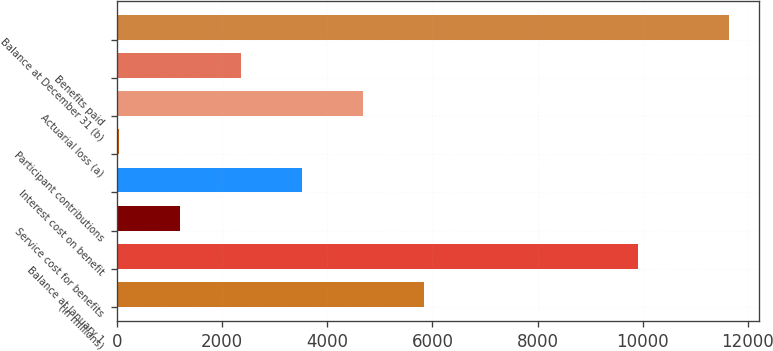<chart> <loc_0><loc_0><loc_500><loc_500><bar_chart><fcel>(In millions)<fcel>Balance at January 1<fcel>Service cost for benefits<fcel>Interest cost on benefit<fcel>Participant contributions<fcel>Actuarial loss (a)<fcel>Benefits paid<fcel>Balance at December 31 (b)<nl><fcel>5837<fcel>9907<fcel>1197<fcel>3517<fcel>37<fcel>4677<fcel>2357<fcel>11637<nl></chart> 